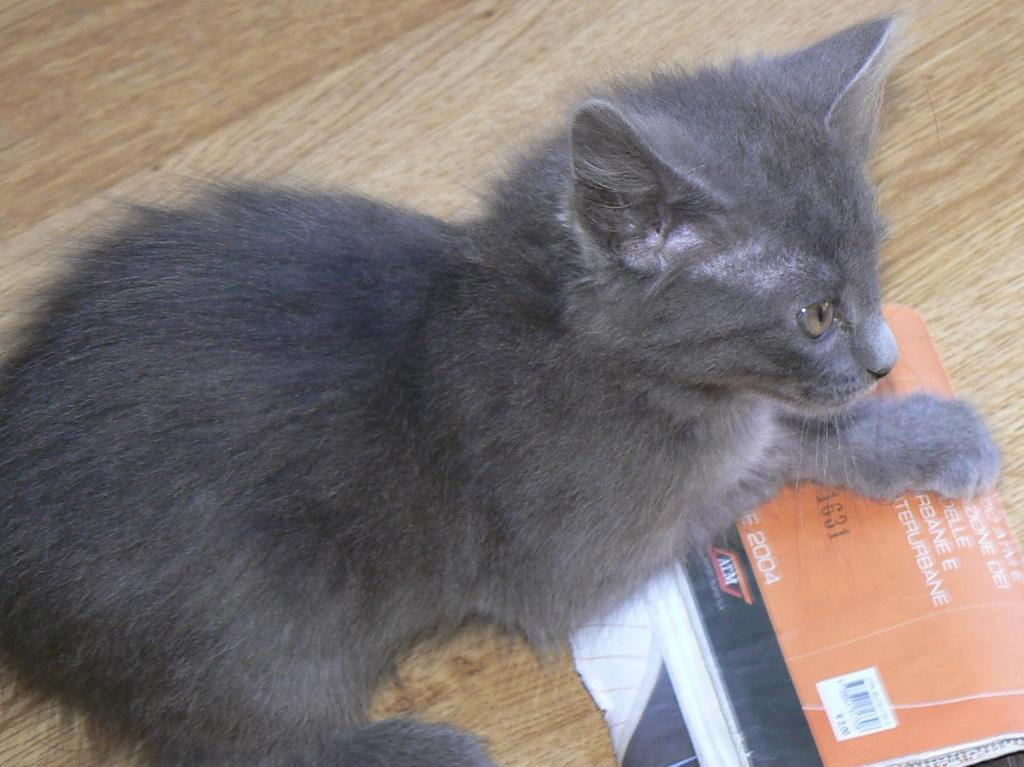What type of animal is in the image? There is a black cat in the image. What is the cat lying on? The cat is lying on a wooden surface. What color is the object in the image? The object in the image is orange in color. What type of structure does the cat use to invent new money in the image? There is no structure, invention, or money present in the image; it only features a black cat lying on a wooden surface and an orange object. 